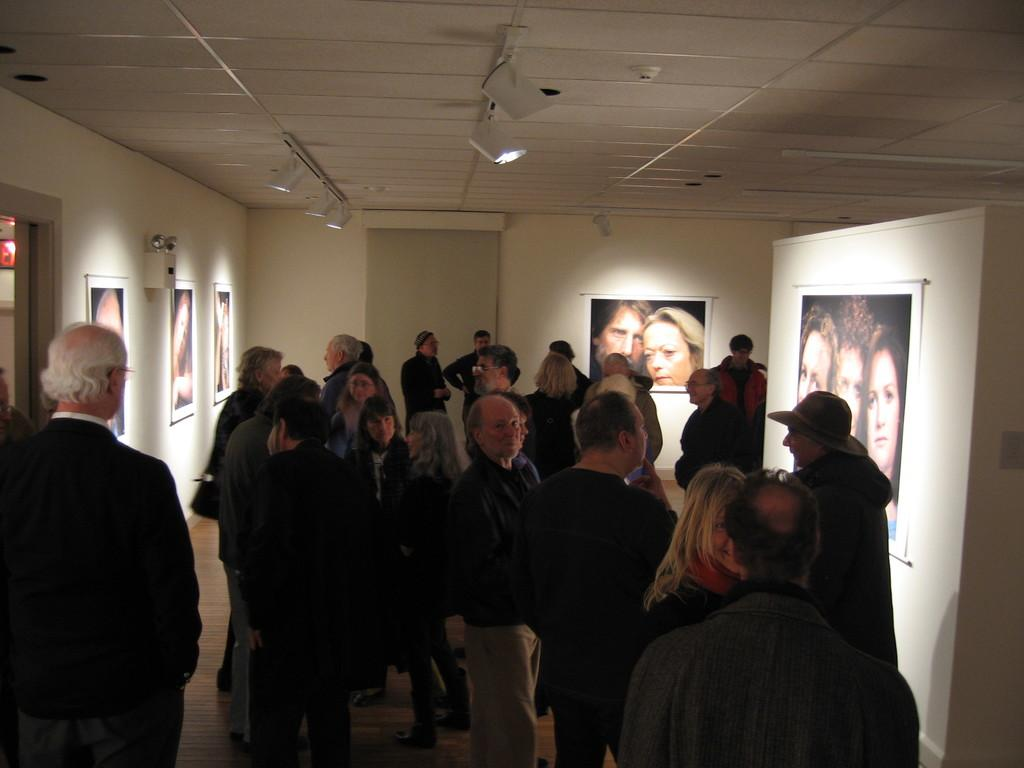How many people are present in the image? There are many people in the image. What can be seen on the wall in the image? There are different pictures attached to the wall in the image. What type of addition problem can be solved using the pictures on the wall in the image? There is no addition problem present in the image, as it only features people and pictures on the wall. How fast are the people running in the image? The people in the image are not running; they are standing or walking. 